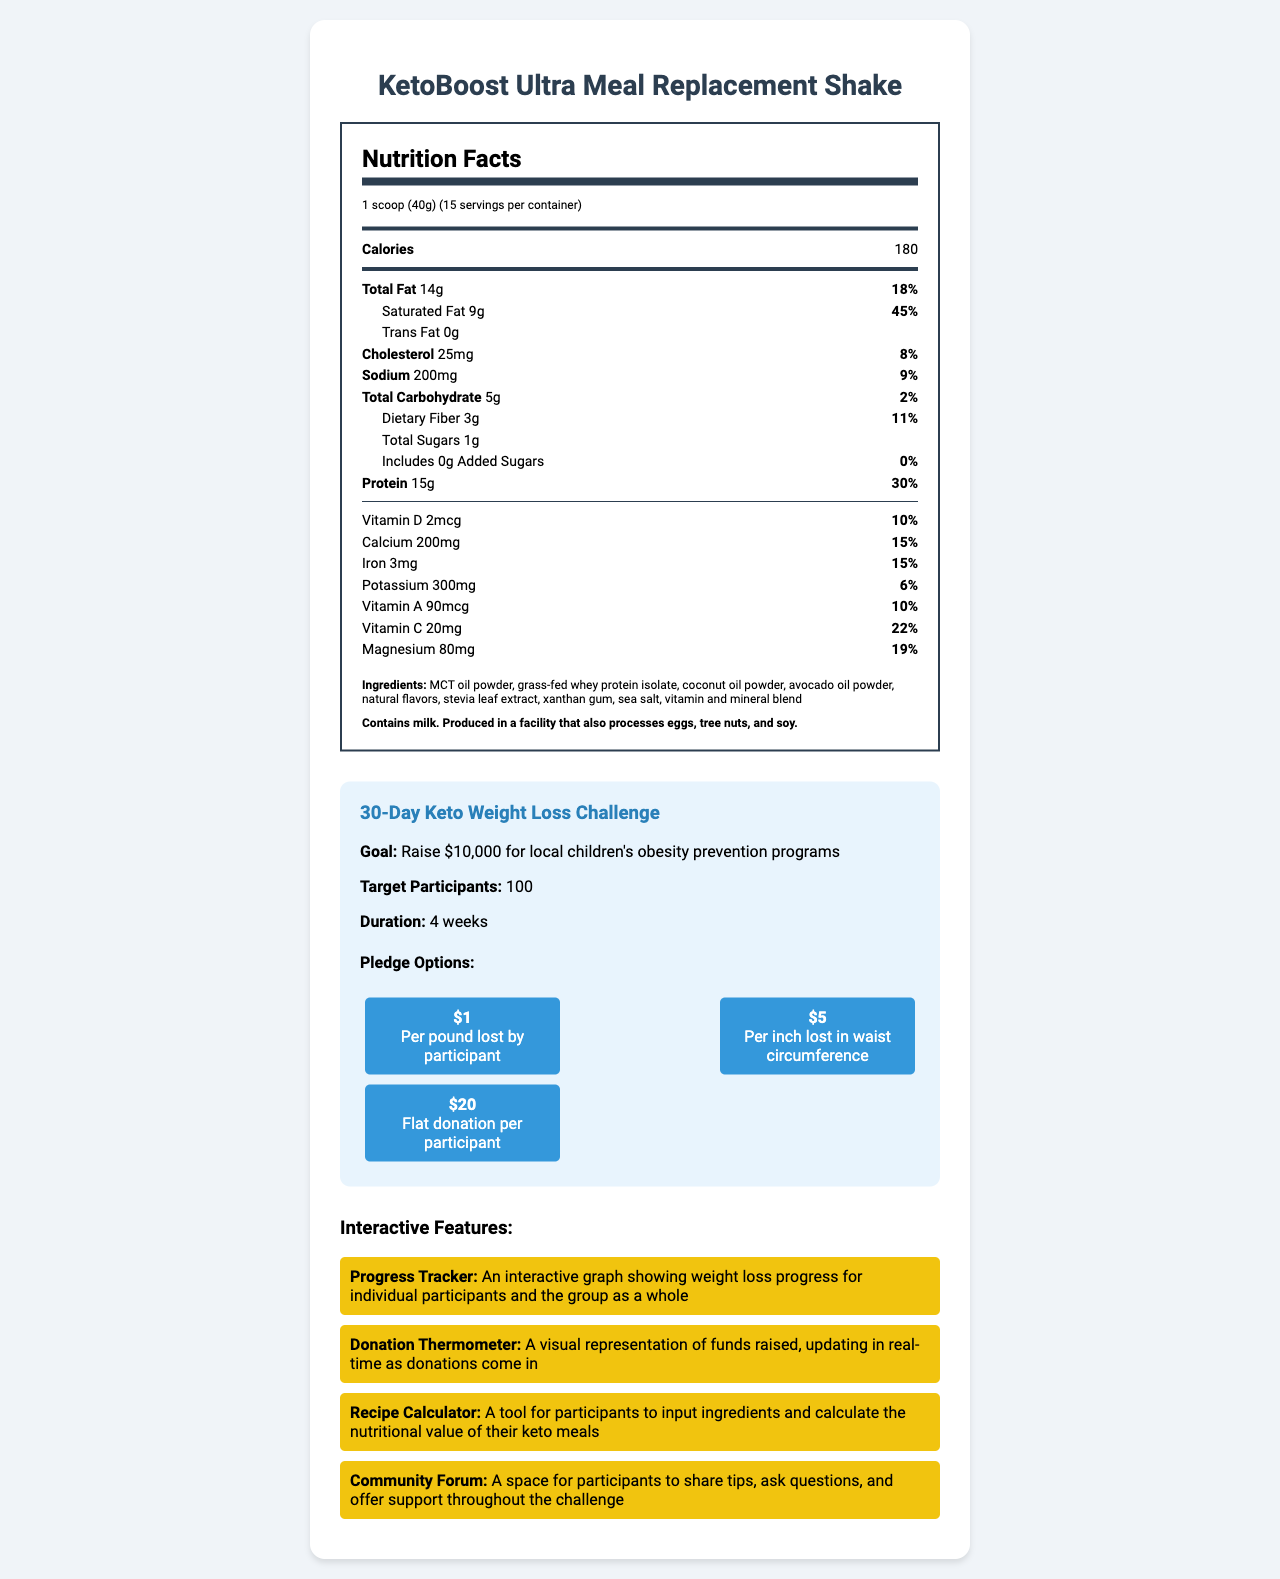who is the product designed for? The product description states it is designed to support weight loss goals during a 30-day fundraising challenge.
Answer: Participants in a 30-day fundraising challenge focused on weight loss what is the serving size? The serving size is listed as "1 scoop (40g)" at the beginning of the Nutrition Facts label.
Answer: 1 scoop (40g) how many servings are there in one container? The document specifies that there are 15 servings per container.
Answer: 15 how many grams of protein does each serving contain? The Nutrition Facts section lists "Protein" as 15g per serving with a daily value of 30%.
Answer: 15g what allergen is mentioned in the allergen information? The allergen information states "Contains milk. Produced in a facility that also processes eggs, tree nuts, and soy."
Answer: Milk what percentage of the daily value of calcium does one serving provide? The Nutrition Facts label shows that one serving provides 15% of the daily value for calcium.
Answer: 15% what are the three options for pledges participants can choose during the fundraising campaign? The fundraising campaign information lists the three pledge options.
Answer: $1 per pound lost, $5 per inch lost in waist circumference, $20 flat donation which ingredient is listed second in the ingredients list? A. Coconut oil powder B. Grass-fed whey protein isolate C. MCT oil powder D. Avocado oil powder The second ingredient listed is "grass-fed whey protein isolate."
Answer: B which of the following features helps participants calculate the nutritional value of their meals? A. Progress Tracker B. Donation Thermometer C. Recipe Calculator D. Community Forum The Recipe Calculator is a tool for participants to input ingredients and calculate the nutritional value of their keto meals.
Answer: C is there any trans fat in the KetoBoost Ultra Meal Replacement Shake? The Nutrition Facts section lists "Trans Fat" as 0g.
Answer: No does the product contain any added sugars? The Nutrition Facts label indicates "Added Sugars" amount as 0g and daily value as 0%.
Answer: No summarize the document The document offers a comprehensive overview, including the product description, nutritional details, lists of ingredients and allergens, goals of the weight loss challenge, pledge options for the campaign, and various interactive tools to engage participants.
Answer: The document showcases the KetoBoost Ultra Meal Replacement Shake, a keto-friendly meal replacement designed for a 30-day weight loss challenge fundraiser. It details the product’s nutritional information, ingredients, and allergens. It also highlights the fundraising campaign's goals, pledge options, and interactive features for participants. what is the magnesium content per serving? A. 50mg B. 70mg C. 80mg D. 100mg The Nutrition Facts label shows "Magnesium" content as 80mg per serving with a daily value of 19%.
Answer: C is Vitamin C content given in micrograms or milligrams? The document lists "Vitamin C" as 20mg with a daily value of 22%.
Answer: Milligrams how many interactive features are mentioned in the document? The interactive features section lists four distinct features: Progress Tracker, Donation Thermometer, Recipe Calculator, and Community Forum.
Answer: 4 who are the pledge options designed for? The pledge options are outlined in the fundraising campaign information, indicating they are meant for participants or supporters who wish to donate based on the progress made by participants.
Answer: Participants or supporters of the weight loss challenge what brand manufactures KetoBoost Ultra Meal Replacement Shake? The document does not provide information about the manufacturer or brand behind the product.
Answer: Cannot be determined 